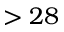<formula> <loc_0><loc_0><loc_500><loc_500>> 2 8</formula> 